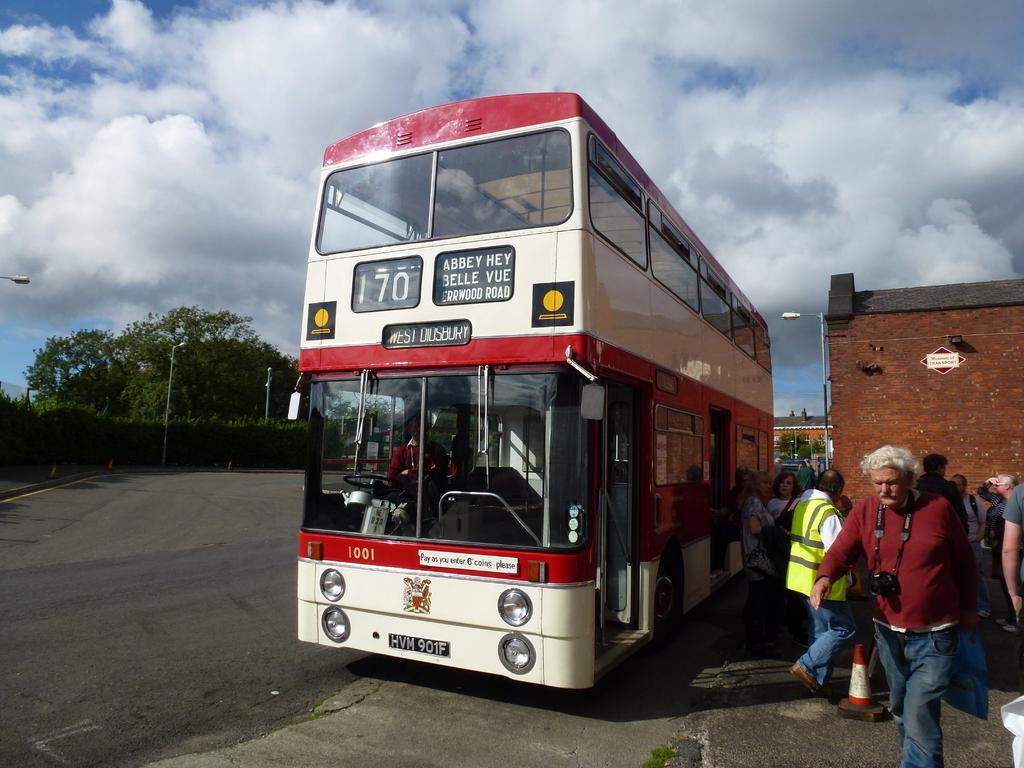<image>
Give a short and clear explanation of the subsequent image. Double bunked Bus with the number 170, includes people getting off the bus. 